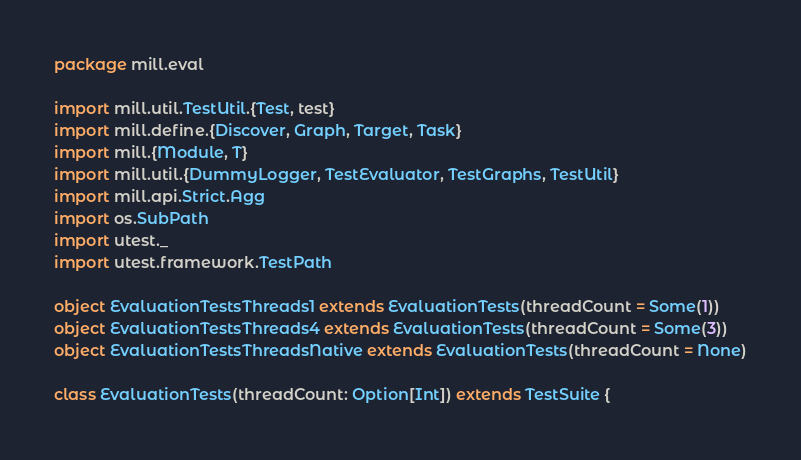<code> <loc_0><loc_0><loc_500><loc_500><_Scala_>package mill.eval

import mill.util.TestUtil.{Test, test}
import mill.define.{Discover, Graph, Target, Task}
import mill.{Module, T}
import mill.util.{DummyLogger, TestEvaluator, TestGraphs, TestUtil}
import mill.api.Strict.Agg
import os.SubPath
import utest._
import utest.framework.TestPath

object EvaluationTestsThreads1 extends EvaluationTests(threadCount = Some(1))
object EvaluationTestsThreads4 extends EvaluationTests(threadCount = Some(3))
object EvaluationTestsThreadsNative extends EvaluationTests(threadCount = None)

class EvaluationTests(threadCount: Option[Int]) extends TestSuite {
</code> 